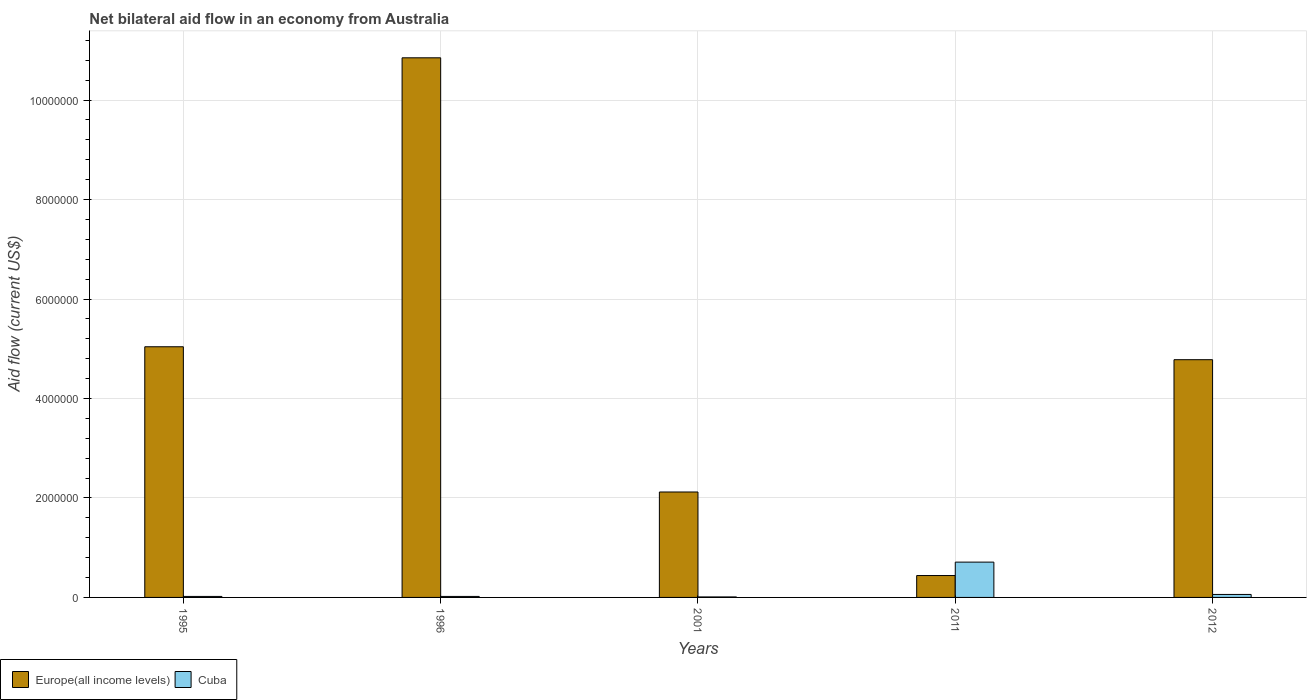How many different coloured bars are there?
Your response must be concise. 2. How many groups of bars are there?
Ensure brevity in your answer.  5. Are the number of bars per tick equal to the number of legend labels?
Your response must be concise. Yes. How many bars are there on the 2nd tick from the left?
Keep it short and to the point. 2. How many bars are there on the 4th tick from the right?
Offer a very short reply. 2. What is the label of the 4th group of bars from the left?
Make the answer very short. 2011. In how many cases, is the number of bars for a given year not equal to the number of legend labels?
Provide a short and direct response. 0. Across all years, what is the maximum net bilateral aid flow in Cuba?
Ensure brevity in your answer.  7.10e+05. In which year was the net bilateral aid flow in Cuba maximum?
Your answer should be very brief. 2011. In which year was the net bilateral aid flow in Cuba minimum?
Your answer should be compact. 2001. What is the total net bilateral aid flow in Cuba in the graph?
Your answer should be compact. 8.20e+05. What is the difference between the net bilateral aid flow in Cuba in 2001 and that in 2011?
Give a very brief answer. -7.00e+05. What is the difference between the net bilateral aid flow in Cuba in 2012 and the net bilateral aid flow in Europe(all income levels) in 1996?
Provide a short and direct response. -1.08e+07. What is the average net bilateral aid flow in Cuba per year?
Offer a very short reply. 1.64e+05. In the year 1996, what is the difference between the net bilateral aid flow in Europe(all income levels) and net bilateral aid flow in Cuba?
Provide a succinct answer. 1.08e+07. What is the ratio of the net bilateral aid flow in Europe(all income levels) in 1996 to that in 2001?
Offer a terse response. 5.12. What is the difference between the highest and the second highest net bilateral aid flow in Cuba?
Offer a very short reply. 6.50e+05. What is the difference between the highest and the lowest net bilateral aid flow in Europe(all income levels)?
Provide a short and direct response. 1.04e+07. In how many years, is the net bilateral aid flow in Cuba greater than the average net bilateral aid flow in Cuba taken over all years?
Your answer should be compact. 1. What does the 1st bar from the left in 1995 represents?
Give a very brief answer. Europe(all income levels). What does the 1st bar from the right in 1996 represents?
Your answer should be compact. Cuba. How many bars are there?
Provide a succinct answer. 10. Are all the bars in the graph horizontal?
Provide a succinct answer. No. How many years are there in the graph?
Offer a terse response. 5. What is the difference between two consecutive major ticks on the Y-axis?
Offer a very short reply. 2.00e+06. How many legend labels are there?
Your answer should be compact. 2. What is the title of the graph?
Keep it short and to the point. Net bilateral aid flow in an economy from Australia. Does "Sub-Saharan Africa (all income levels)" appear as one of the legend labels in the graph?
Make the answer very short. No. What is the label or title of the Y-axis?
Ensure brevity in your answer.  Aid flow (current US$). What is the Aid flow (current US$) of Europe(all income levels) in 1995?
Provide a short and direct response. 5.04e+06. What is the Aid flow (current US$) of Cuba in 1995?
Offer a terse response. 2.00e+04. What is the Aid flow (current US$) of Europe(all income levels) in 1996?
Make the answer very short. 1.08e+07. What is the Aid flow (current US$) of Europe(all income levels) in 2001?
Your answer should be compact. 2.12e+06. What is the Aid flow (current US$) of Cuba in 2001?
Offer a very short reply. 10000. What is the Aid flow (current US$) in Cuba in 2011?
Offer a terse response. 7.10e+05. What is the Aid flow (current US$) in Europe(all income levels) in 2012?
Make the answer very short. 4.78e+06. Across all years, what is the maximum Aid flow (current US$) of Europe(all income levels)?
Offer a terse response. 1.08e+07. Across all years, what is the maximum Aid flow (current US$) in Cuba?
Make the answer very short. 7.10e+05. What is the total Aid flow (current US$) in Europe(all income levels) in the graph?
Give a very brief answer. 2.32e+07. What is the total Aid flow (current US$) of Cuba in the graph?
Keep it short and to the point. 8.20e+05. What is the difference between the Aid flow (current US$) in Europe(all income levels) in 1995 and that in 1996?
Your answer should be very brief. -5.81e+06. What is the difference between the Aid flow (current US$) of Cuba in 1995 and that in 1996?
Keep it short and to the point. 0. What is the difference between the Aid flow (current US$) of Europe(all income levels) in 1995 and that in 2001?
Provide a short and direct response. 2.92e+06. What is the difference between the Aid flow (current US$) in Cuba in 1995 and that in 2001?
Make the answer very short. 10000. What is the difference between the Aid flow (current US$) in Europe(all income levels) in 1995 and that in 2011?
Keep it short and to the point. 4.60e+06. What is the difference between the Aid flow (current US$) in Cuba in 1995 and that in 2011?
Keep it short and to the point. -6.90e+05. What is the difference between the Aid flow (current US$) of Europe(all income levels) in 1996 and that in 2001?
Your answer should be compact. 8.73e+06. What is the difference between the Aid flow (current US$) in Cuba in 1996 and that in 2001?
Give a very brief answer. 10000. What is the difference between the Aid flow (current US$) in Europe(all income levels) in 1996 and that in 2011?
Offer a very short reply. 1.04e+07. What is the difference between the Aid flow (current US$) of Cuba in 1996 and that in 2011?
Provide a short and direct response. -6.90e+05. What is the difference between the Aid flow (current US$) in Europe(all income levels) in 1996 and that in 2012?
Make the answer very short. 6.07e+06. What is the difference between the Aid flow (current US$) of Europe(all income levels) in 2001 and that in 2011?
Your response must be concise. 1.68e+06. What is the difference between the Aid flow (current US$) of Cuba in 2001 and that in 2011?
Your response must be concise. -7.00e+05. What is the difference between the Aid flow (current US$) in Europe(all income levels) in 2001 and that in 2012?
Keep it short and to the point. -2.66e+06. What is the difference between the Aid flow (current US$) of Europe(all income levels) in 2011 and that in 2012?
Your answer should be very brief. -4.34e+06. What is the difference between the Aid flow (current US$) in Cuba in 2011 and that in 2012?
Your answer should be very brief. 6.50e+05. What is the difference between the Aid flow (current US$) in Europe(all income levels) in 1995 and the Aid flow (current US$) in Cuba in 1996?
Ensure brevity in your answer.  5.02e+06. What is the difference between the Aid flow (current US$) of Europe(all income levels) in 1995 and the Aid flow (current US$) of Cuba in 2001?
Ensure brevity in your answer.  5.03e+06. What is the difference between the Aid flow (current US$) of Europe(all income levels) in 1995 and the Aid flow (current US$) of Cuba in 2011?
Offer a terse response. 4.33e+06. What is the difference between the Aid flow (current US$) of Europe(all income levels) in 1995 and the Aid flow (current US$) of Cuba in 2012?
Give a very brief answer. 4.98e+06. What is the difference between the Aid flow (current US$) in Europe(all income levels) in 1996 and the Aid flow (current US$) in Cuba in 2001?
Provide a succinct answer. 1.08e+07. What is the difference between the Aid flow (current US$) in Europe(all income levels) in 1996 and the Aid flow (current US$) in Cuba in 2011?
Ensure brevity in your answer.  1.01e+07. What is the difference between the Aid flow (current US$) of Europe(all income levels) in 1996 and the Aid flow (current US$) of Cuba in 2012?
Your answer should be very brief. 1.08e+07. What is the difference between the Aid flow (current US$) of Europe(all income levels) in 2001 and the Aid flow (current US$) of Cuba in 2011?
Your answer should be compact. 1.41e+06. What is the difference between the Aid flow (current US$) in Europe(all income levels) in 2001 and the Aid flow (current US$) in Cuba in 2012?
Provide a short and direct response. 2.06e+06. What is the average Aid flow (current US$) in Europe(all income levels) per year?
Your response must be concise. 4.65e+06. What is the average Aid flow (current US$) in Cuba per year?
Provide a short and direct response. 1.64e+05. In the year 1995, what is the difference between the Aid flow (current US$) of Europe(all income levels) and Aid flow (current US$) of Cuba?
Keep it short and to the point. 5.02e+06. In the year 1996, what is the difference between the Aid flow (current US$) of Europe(all income levels) and Aid flow (current US$) of Cuba?
Your answer should be very brief. 1.08e+07. In the year 2001, what is the difference between the Aid flow (current US$) of Europe(all income levels) and Aid flow (current US$) of Cuba?
Make the answer very short. 2.11e+06. In the year 2012, what is the difference between the Aid flow (current US$) in Europe(all income levels) and Aid flow (current US$) in Cuba?
Your answer should be compact. 4.72e+06. What is the ratio of the Aid flow (current US$) of Europe(all income levels) in 1995 to that in 1996?
Ensure brevity in your answer.  0.46. What is the ratio of the Aid flow (current US$) in Cuba in 1995 to that in 1996?
Your answer should be very brief. 1. What is the ratio of the Aid flow (current US$) in Europe(all income levels) in 1995 to that in 2001?
Your answer should be compact. 2.38. What is the ratio of the Aid flow (current US$) of Europe(all income levels) in 1995 to that in 2011?
Provide a short and direct response. 11.45. What is the ratio of the Aid flow (current US$) of Cuba in 1995 to that in 2011?
Provide a short and direct response. 0.03. What is the ratio of the Aid flow (current US$) of Europe(all income levels) in 1995 to that in 2012?
Your response must be concise. 1.05. What is the ratio of the Aid flow (current US$) of Cuba in 1995 to that in 2012?
Offer a very short reply. 0.33. What is the ratio of the Aid flow (current US$) of Europe(all income levels) in 1996 to that in 2001?
Provide a short and direct response. 5.12. What is the ratio of the Aid flow (current US$) in Europe(all income levels) in 1996 to that in 2011?
Make the answer very short. 24.66. What is the ratio of the Aid flow (current US$) in Cuba in 1996 to that in 2011?
Offer a terse response. 0.03. What is the ratio of the Aid flow (current US$) of Europe(all income levels) in 1996 to that in 2012?
Give a very brief answer. 2.27. What is the ratio of the Aid flow (current US$) of Europe(all income levels) in 2001 to that in 2011?
Make the answer very short. 4.82. What is the ratio of the Aid flow (current US$) in Cuba in 2001 to that in 2011?
Make the answer very short. 0.01. What is the ratio of the Aid flow (current US$) in Europe(all income levels) in 2001 to that in 2012?
Offer a very short reply. 0.44. What is the ratio of the Aid flow (current US$) in Europe(all income levels) in 2011 to that in 2012?
Offer a terse response. 0.09. What is the ratio of the Aid flow (current US$) of Cuba in 2011 to that in 2012?
Your answer should be very brief. 11.83. What is the difference between the highest and the second highest Aid flow (current US$) of Europe(all income levels)?
Offer a terse response. 5.81e+06. What is the difference between the highest and the second highest Aid flow (current US$) of Cuba?
Offer a terse response. 6.50e+05. What is the difference between the highest and the lowest Aid flow (current US$) in Europe(all income levels)?
Your answer should be very brief. 1.04e+07. 